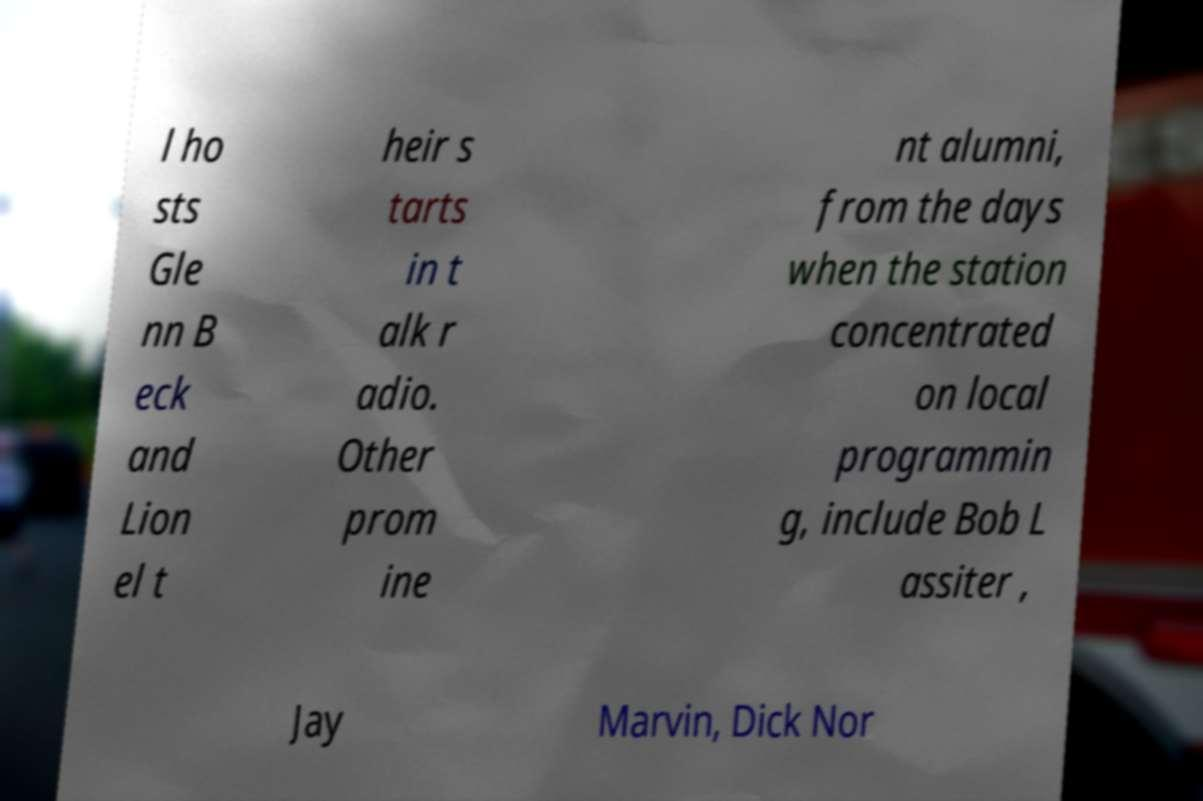There's text embedded in this image that I need extracted. Can you transcribe it verbatim? l ho sts Gle nn B eck and Lion el t heir s tarts in t alk r adio. Other prom ine nt alumni, from the days when the station concentrated on local programmin g, include Bob L assiter , Jay Marvin, Dick Nor 